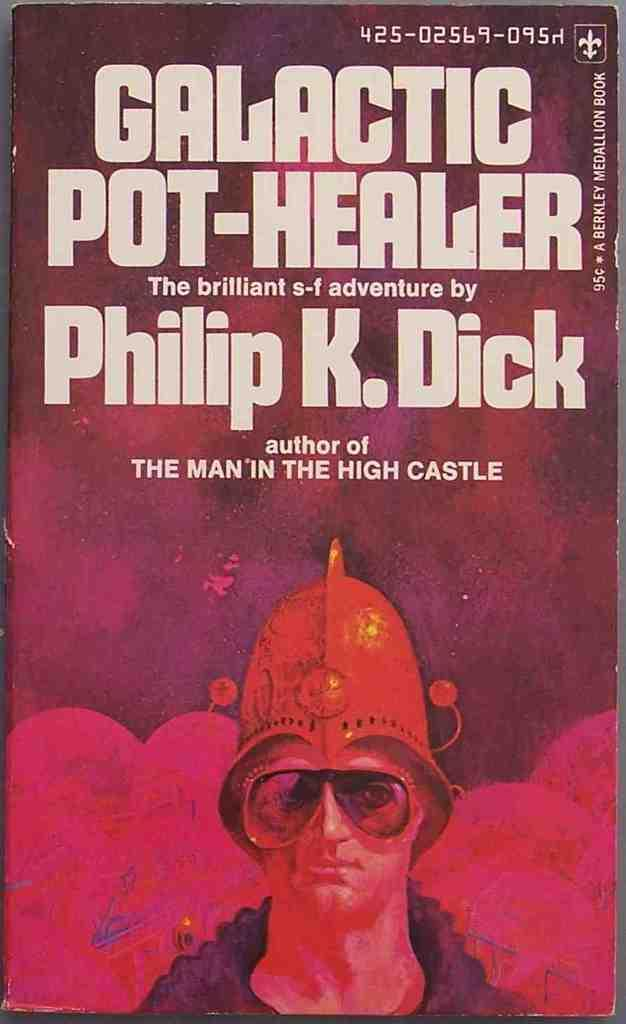What is the main object in the image? There is a poster in the image. What is shown on the poster? There is a person depicted on the poster. What else can be seen on the poster besides the person? There is text present on the poster. What color is the sock worn by the person on the poster? There is no sock visible on the person depicted on the poster in the image. 